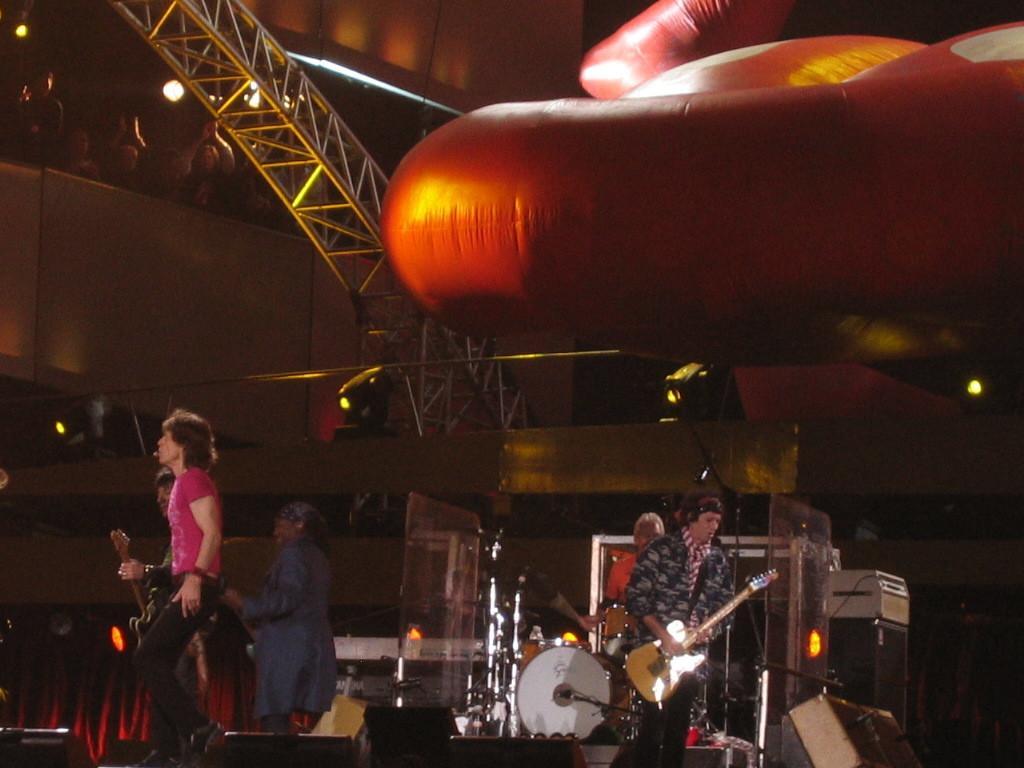Describe this image in one or two sentences. people are performing on the stage. the person at the right is playing guitar. behind them a person is playing drums. people at the left are playing guitar and singing. above them there is a huge red airbag. below that there are lights. at the left top people are standing and watching them. 